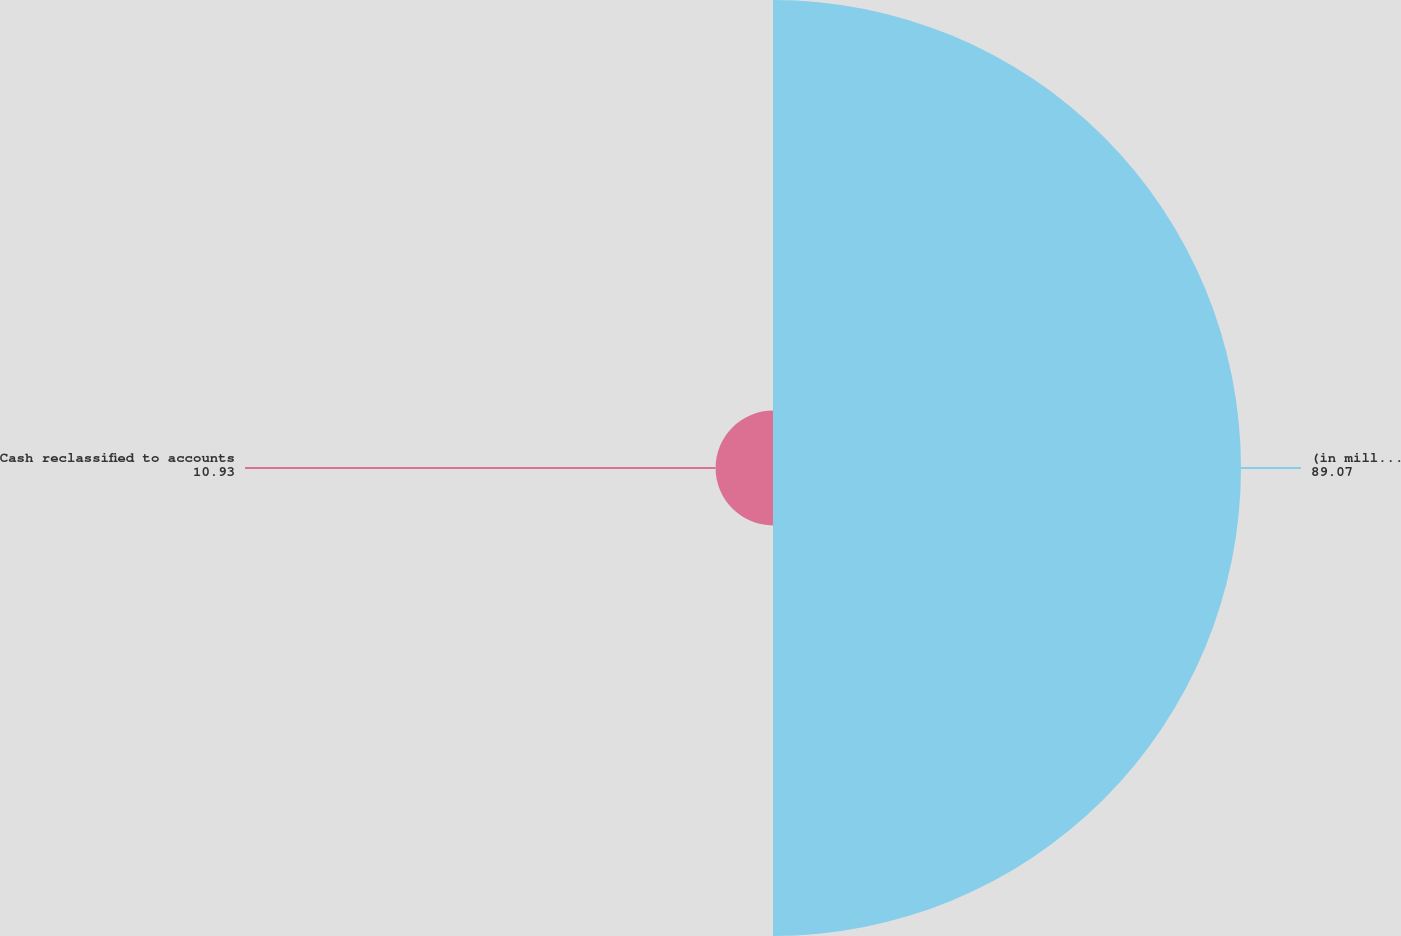Convert chart to OTSL. <chart><loc_0><loc_0><loc_500><loc_500><pie_chart><fcel>(in millions)<fcel>Cash reclassified to accounts<nl><fcel>89.07%<fcel>10.93%<nl></chart> 